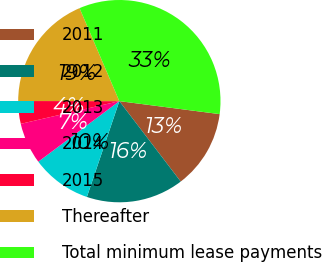Convert chart to OTSL. <chart><loc_0><loc_0><loc_500><loc_500><pie_chart><fcel>2011<fcel>2012<fcel>2013<fcel>2014<fcel>2015<fcel>Thereafter<fcel>Total minimum lease payments<nl><fcel>12.58%<fcel>15.57%<fcel>9.59%<fcel>6.61%<fcel>3.62%<fcel>18.55%<fcel>33.48%<nl></chart> 